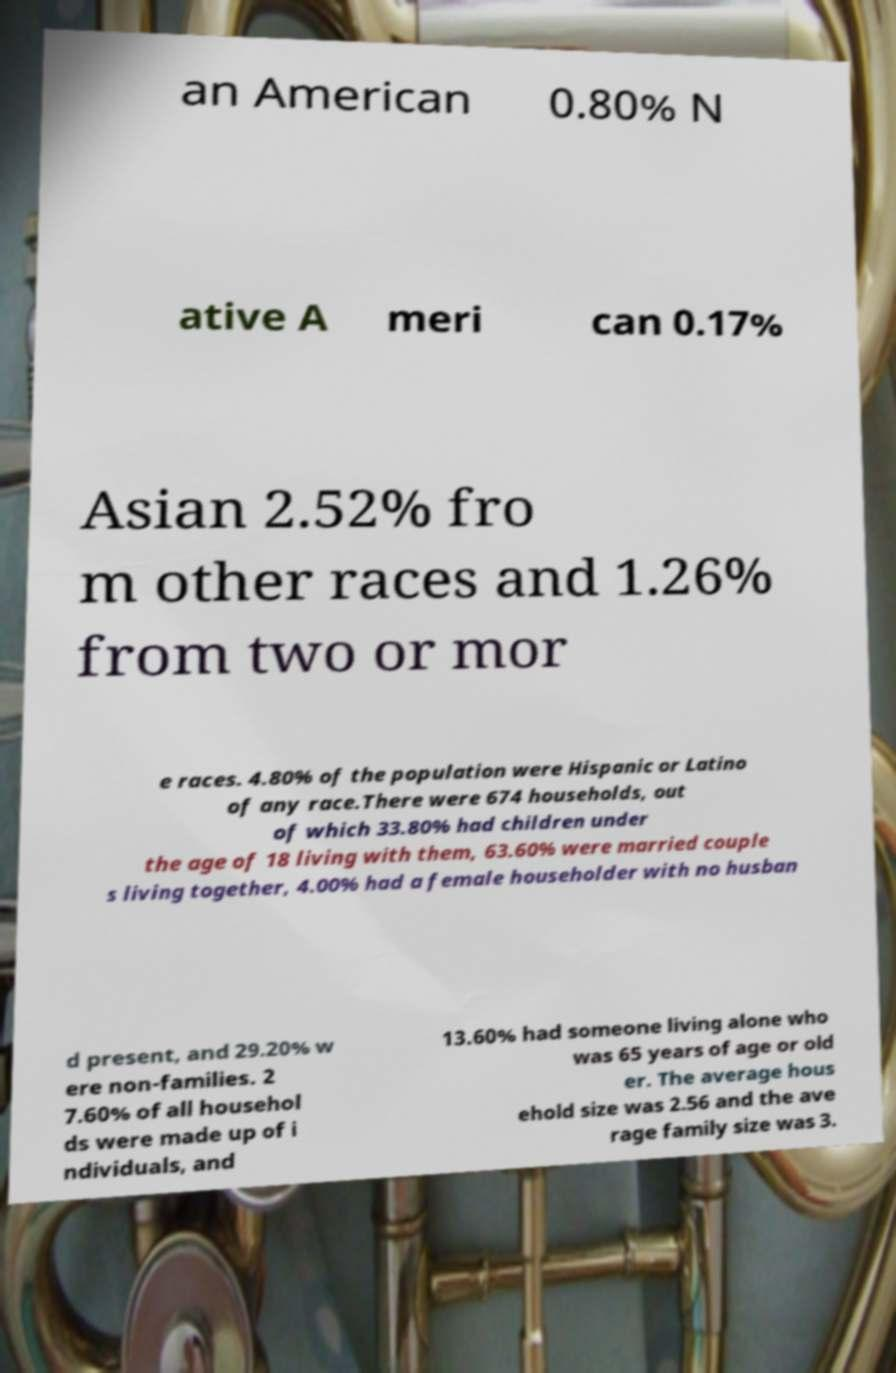Could you assist in decoding the text presented in this image and type it out clearly? an American 0.80% N ative A meri can 0.17% Asian 2.52% fro m other races and 1.26% from two or mor e races. 4.80% of the population were Hispanic or Latino of any race.There were 674 households, out of which 33.80% had children under the age of 18 living with them, 63.60% were married couple s living together, 4.00% had a female householder with no husban d present, and 29.20% w ere non-families. 2 7.60% of all househol ds were made up of i ndividuals, and 13.60% had someone living alone who was 65 years of age or old er. The average hous ehold size was 2.56 and the ave rage family size was 3. 